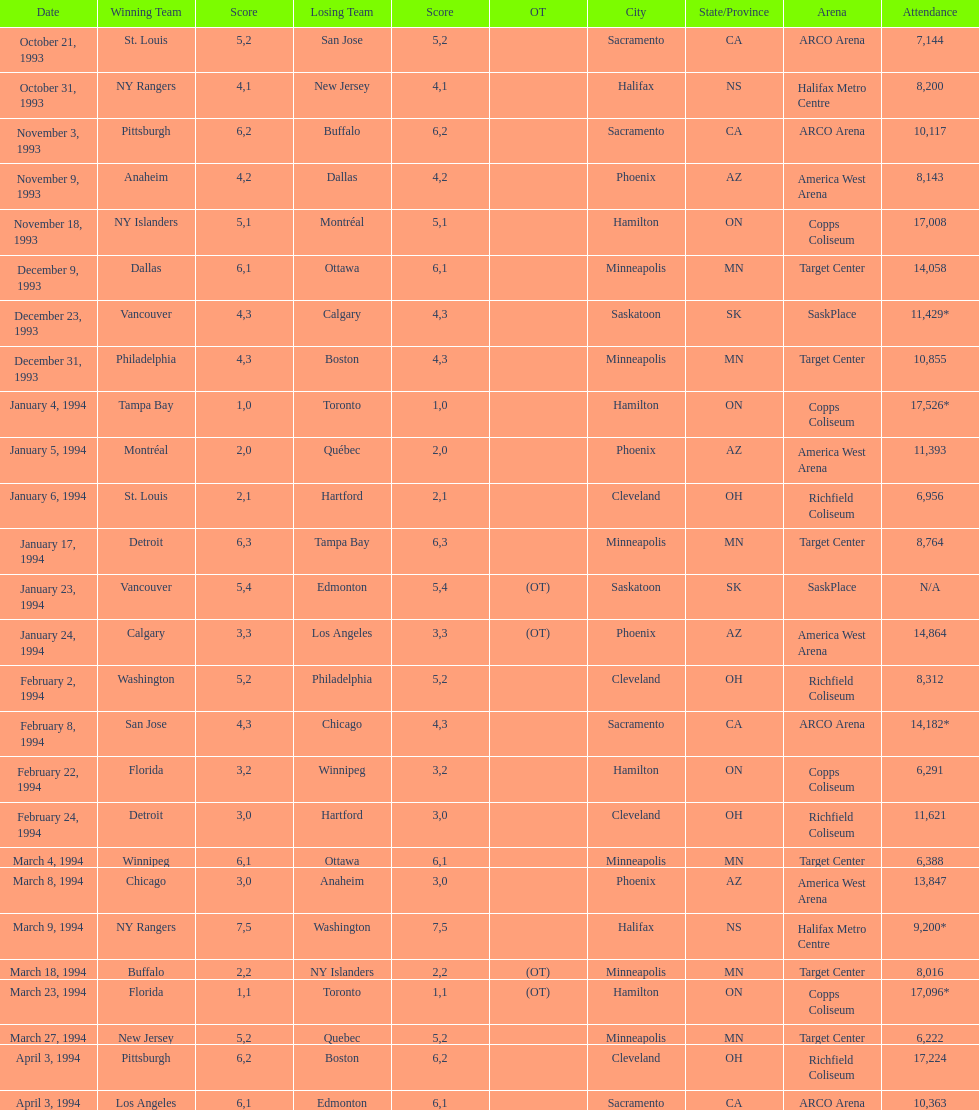Which gathering had more attendees, january 24, 1994, or december 23, 1993? January 4, 1994. 